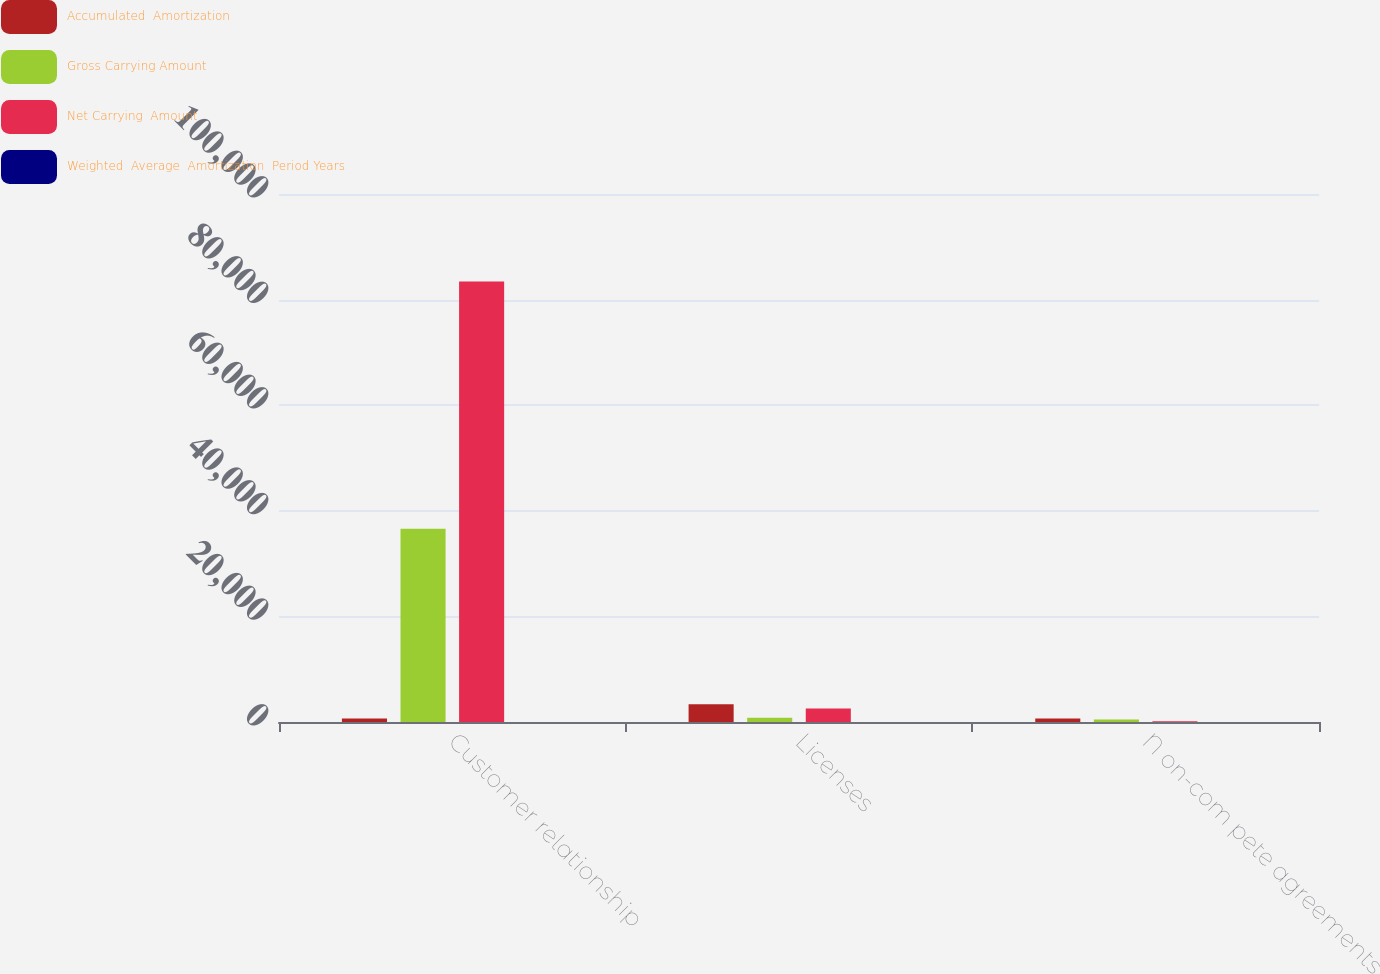Convert chart. <chart><loc_0><loc_0><loc_500><loc_500><stacked_bar_chart><ecel><fcel>Customer relationship<fcel>Licenses<fcel>N on-com pete agreements<nl><fcel>Accumulated  Amortization<fcel>660<fcel>3368<fcel>660<nl><fcel>Gross Carrying Amount<fcel>36593<fcel>807<fcel>495<nl><fcel>Net Carrying  Amount<fcel>83407<fcel>2561<fcel>165<nl><fcel>Weighted  Average  Amortization  Period Years<fcel>6<fcel>5.6<fcel>1<nl></chart> 